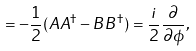Convert formula to latex. <formula><loc_0><loc_0><loc_500><loc_500>= - \frac { 1 } { 2 } ( A A ^ { \dagger } - B B ^ { \dagger } ) = \frac { i } { 2 } \frac { \partial } { \partial \phi } ,</formula> 